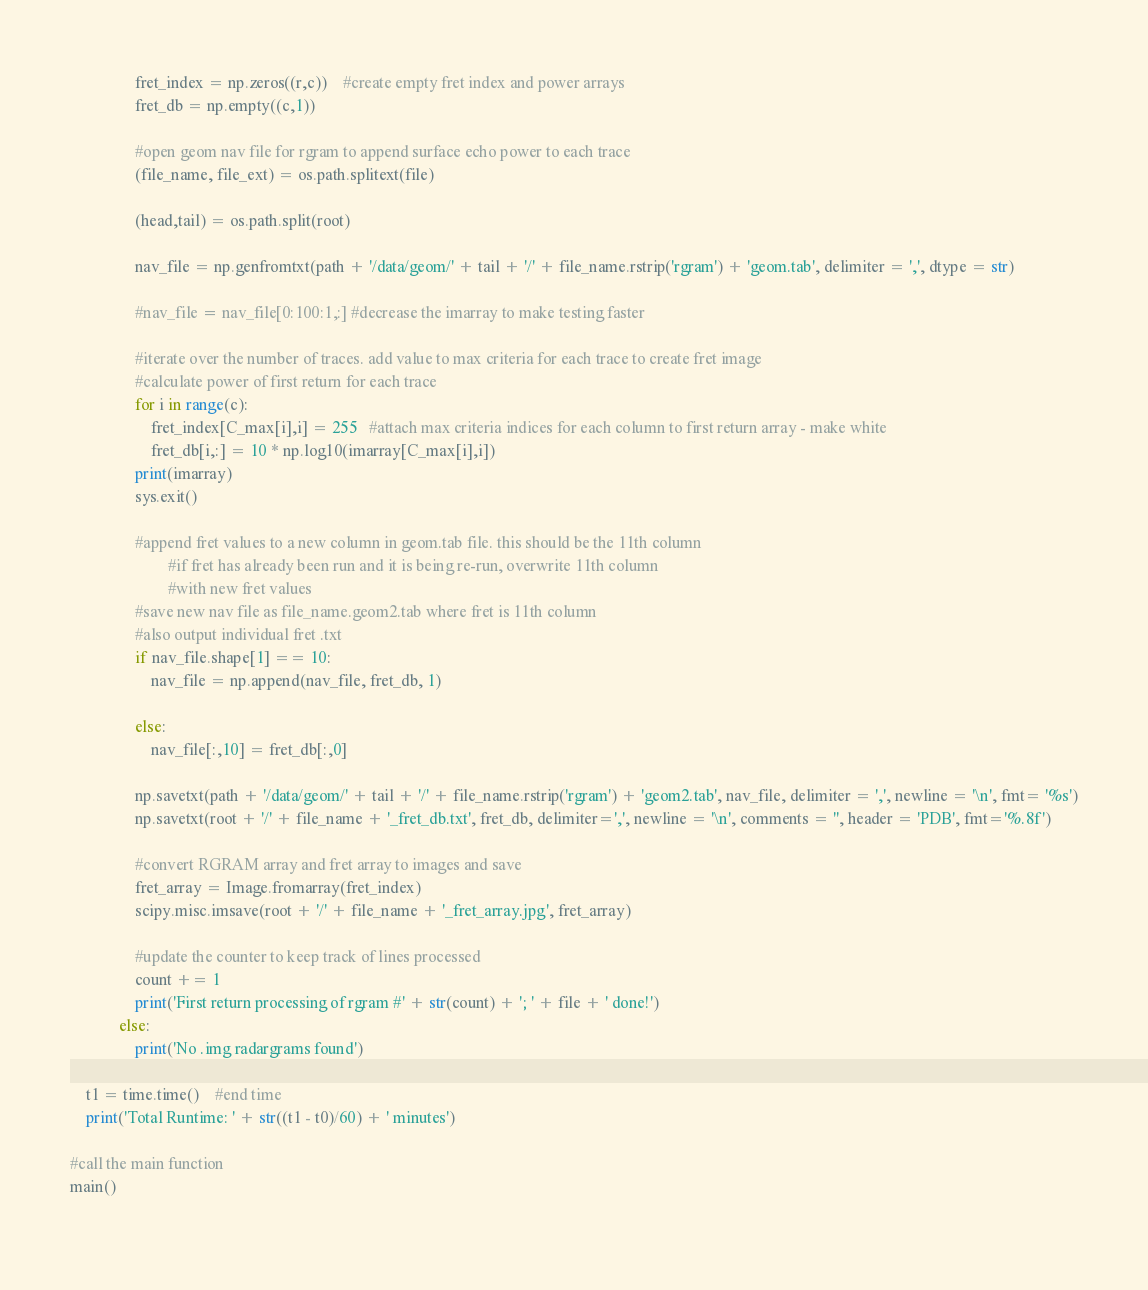Convert code to text. <code><loc_0><loc_0><loc_500><loc_500><_Python_>                fret_index = np.zeros((r,c))	#create empty fret index and power arrays
                fret_db = np.empty((c,1))

                #open geom nav file for rgram to append surface echo power to each trace
                (file_name, file_ext) = os.path.splitext(file)
                
                (head,tail) = os.path.split(root)
                
                nav_file = np.genfromtxt(path + '/data/geom/' + tail + '/' + file_name.rstrip('rgram') + 'geom.tab', delimiter = ',', dtype = str)

                #nav_file = nav_file[0:100:1,:]	#decrease the imarray to make testing faster 
                                
                #iterate over the number of traces. add value to max criteria for each trace to create fret image
                #calculate power of first return for each trace
                for i in range(c):
                    fret_index[C_max[i],i] = 255   #attach max criteria indices for each column to first return array - make white
                    fret_db[i,:] = 10 * np.log10(imarray[C_max[i],i])
                print(imarray)
                sys.exit()

                #append fret values to a new column in geom.tab file. this should be the 11th column
                        #if fret has already been run and it is being re-run, overwrite 11th column
                        #with new fret values
                #save new nav file as file_name.geom2.tab where fret is 11th column
                #also output individual fret .txt
                if nav_file.shape[1] == 10:
                    nav_file = np.append(nav_file, fret_db, 1)

                else:
                    nav_file[:,10] = fret_db[:,0]
                    
                np.savetxt(path + '/data/geom/' + tail + '/' + file_name.rstrip('rgram') + 'geom2.tab', nav_file, delimiter = ',', newline = '\n', fmt= '%s')
                np.savetxt(root + '/' + file_name + '_fret_db.txt', fret_db, delimiter=',', newline = '\n', comments = '', header = 'PDB', fmt='%.8f')

                #convert RGRAM array and fret array to images and save
                fret_array = Image.fromarray(fret_index)
                scipy.misc.imsave(root + '/' + file_name + '_fret_array.jpg', fret_array)
                
                #update the counter to keep track of lines processed
                count += 1
                print('First return processing of rgram #' + str(count) + '; ' + file + ' done!')
            else:
                print('No .img radargrams found')

    t1 = time.time()    #end time
    print('Total Runtime: ' + str((t1 - t0)/60) + ' minutes')

#call the main function
main()
        
</code> 